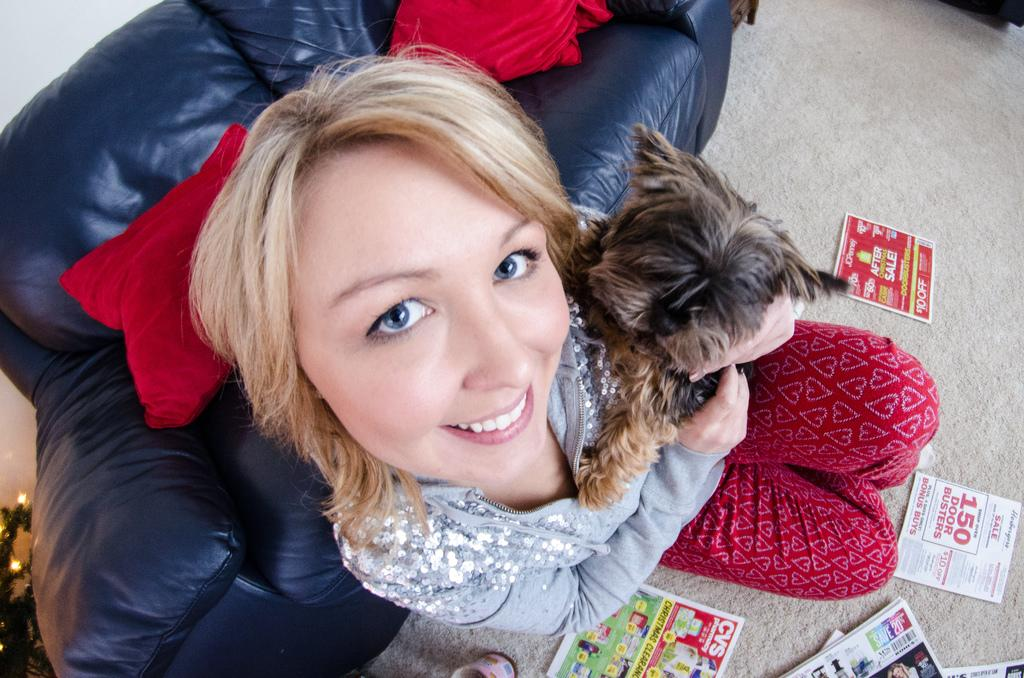What is the person in the image doing? The person is sitting on the floor. What is the person holding in the image? The person is holding a dog. What piece of furniture is visible behind the person? There is a sofa behind the person. What is on the wall behind the sofa? There is a wall behind the sofa. What is on the sofa in the image? There are pillows on the sofa. What is on the floor near the person? There are papers on the floor. What type of cheese is the person eating with their friends in the image? There is no cheese or friends present in the image; it only shows a person sitting on the floor holding a dog. How many tickets does the person have in the image? There are no tickets present in the image. 